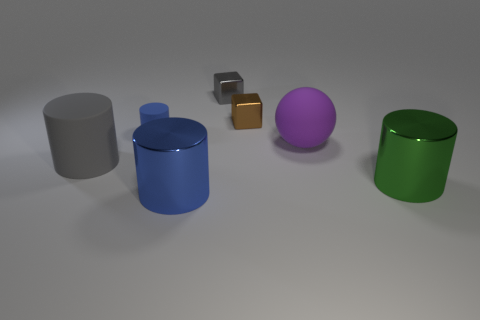How many blue cylinders must be subtracted to get 1 blue cylinders? 1 Add 2 big purple balls. How many objects exist? 9 Subtract all brown cubes. How many blue cylinders are left? 2 Subtract all big cylinders. How many cylinders are left? 1 Subtract 2 cylinders. How many cylinders are left? 2 Subtract all gray cylinders. How many cylinders are left? 3 Subtract all cylinders. How many objects are left? 3 Add 3 blue cylinders. How many blue cylinders exist? 5 Subtract 0 gray spheres. How many objects are left? 7 Subtract all yellow cylinders. Subtract all green balls. How many cylinders are left? 4 